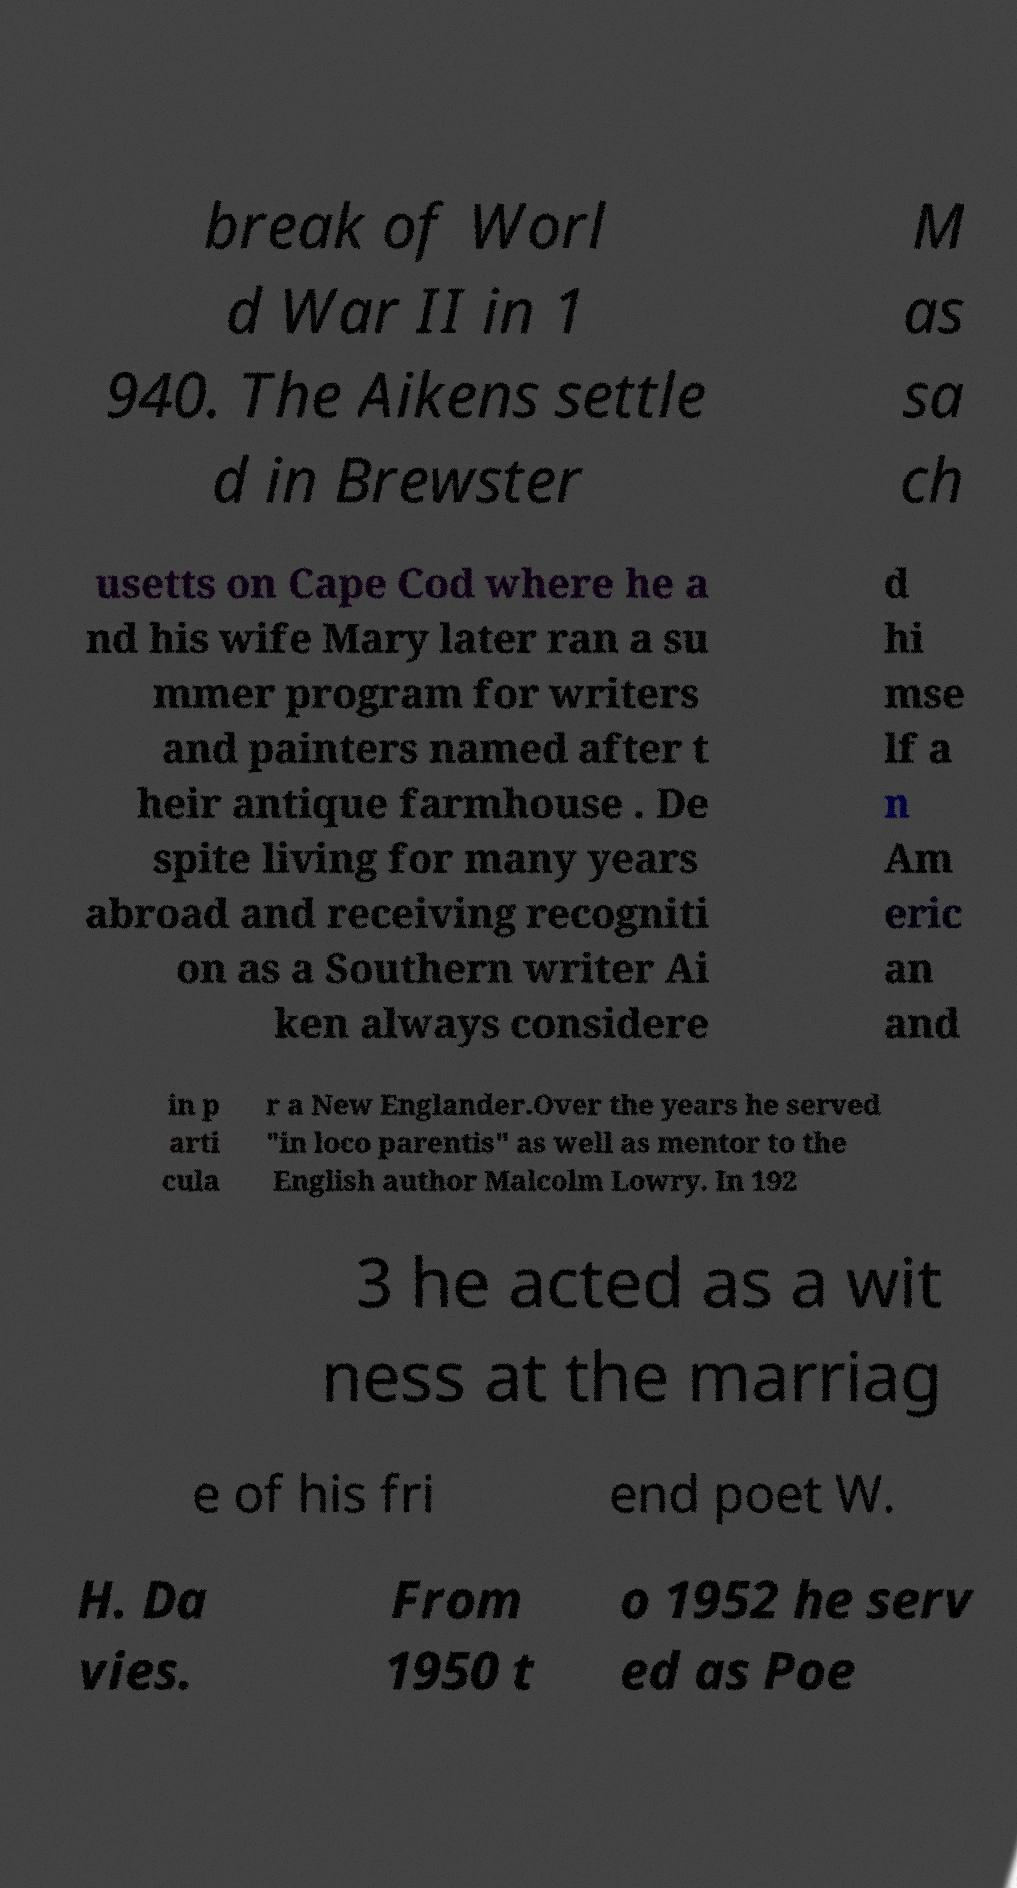Can you read and provide the text displayed in the image?This photo seems to have some interesting text. Can you extract and type it out for me? break of Worl d War II in 1 940. The Aikens settle d in Brewster M as sa ch usetts on Cape Cod where he a nd his wife Mary later ran a su mmer program for writers and painters named after t heir antique farmhouse . De spite living for many years abroad and receiving recogniti on as a Southern writer Ai ken always considere d hi mse lf a n Am eric an and in p arti cula r a New Englander.Over the years he served "in loco parentis" as well as mentor to the English author Malcolm Lowry. In 192 3 he acted as a wit ness at the marriag e of his fri end poet W. H. Da vies. From 1950 t o 1952 he serv ed as Poe 